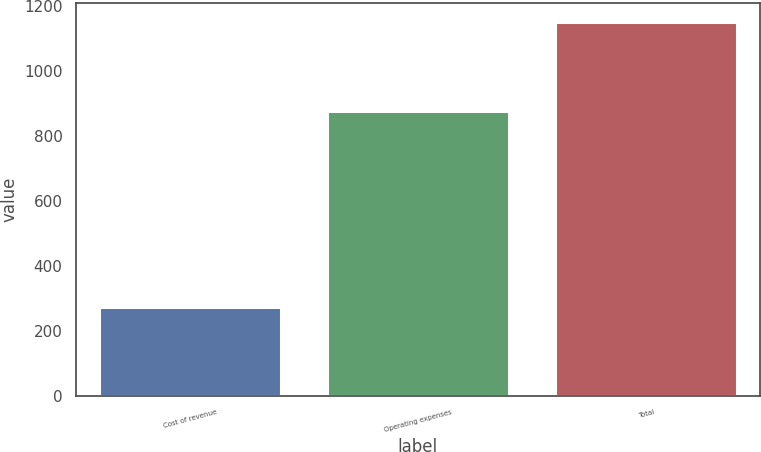<chart> <loc_0><loc_0><loc_500><loc_500><bar_chart><fcel>Cost of revenue<fcel>Operating expenses<fcel>Total<nl><fcel>273.7<fcel>878.1<fcel>1151.8<nl></chart> 